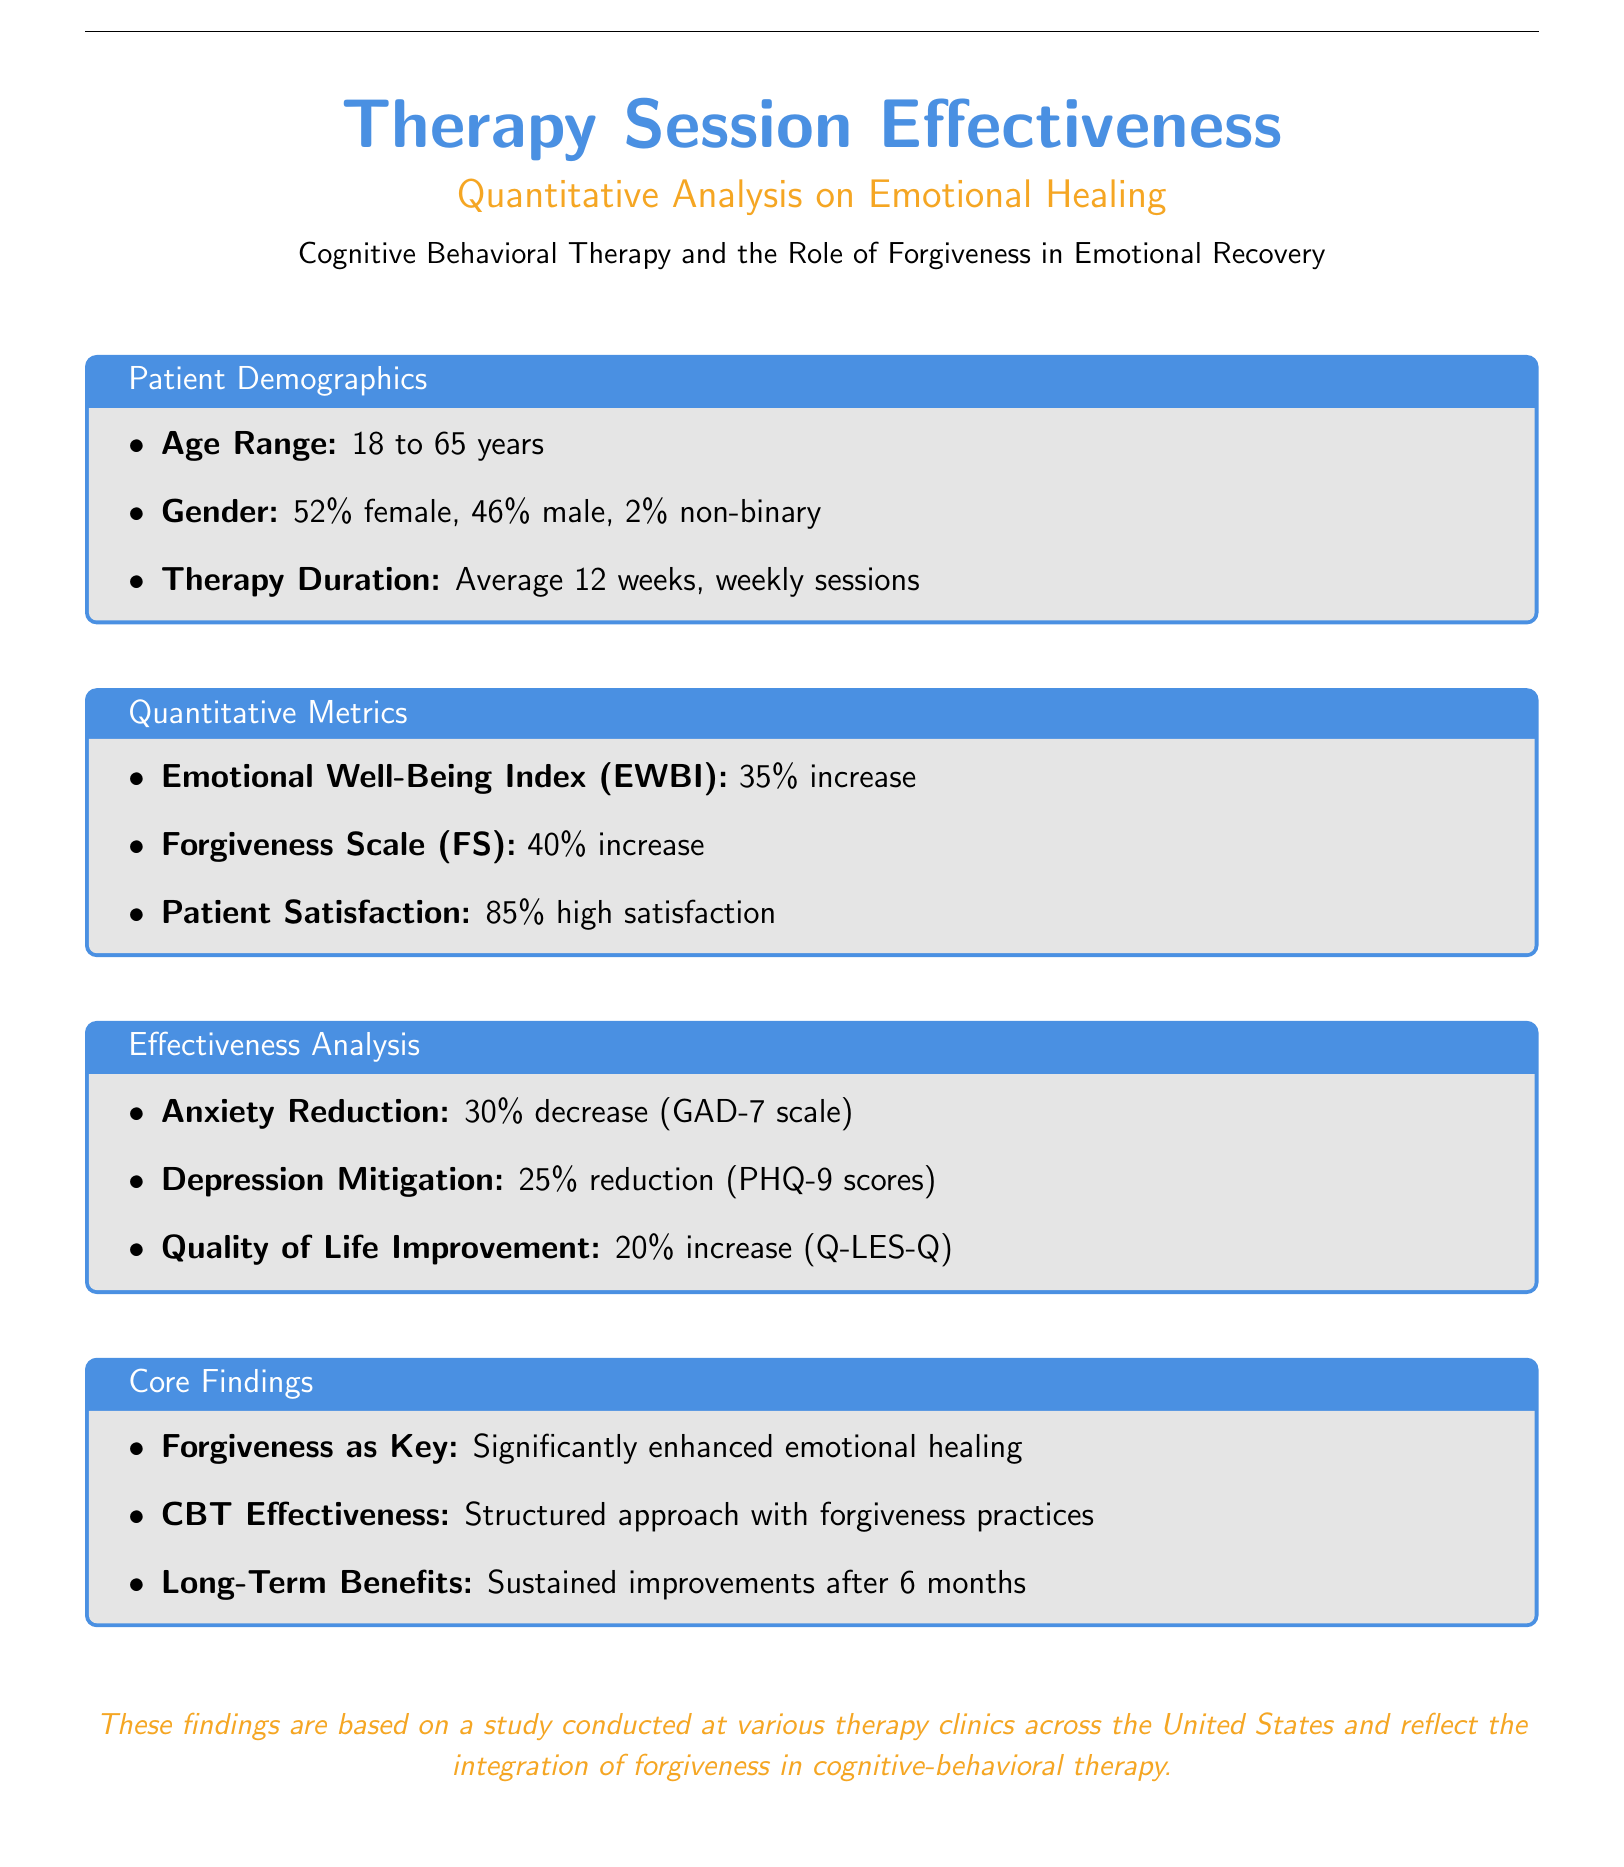What is the average therapy duration? The average therapy duration is mentioned specifically in the Patient Demographics section of the document.
Answer: 12 weeks What percentage of patients reported high satisfaction? Patient satisfaction is quantified in the Quantitative Metrics section of the document.
Answer: 85% What is the increase in the Emotional Well-Being Index? The increase in the Emotional Well-Being Index is provided in the Quantitative Metrics section.
Answer: 35% increase What core finding highlights the role of forgiveness? The core findings indicate the significance of forgiveness in emotional healing, specifically noted in the Core Findings section.
Answer: Forgiveness as Key What is the percentage decrease in anxiety according to the GAD-7 scale? The decrease in anxiety is quantified in the Effectiveness Analysis section and is based on standardized measures.
Answer: 30% decrease What area saw a 25% reduction in scores? The area that saw a 25% reduction is given in the Effectiveness Analysis, specifically referring to measurements related to patient states.
Answer: Depression Mitigation What is the percentage increase in Quality of Life Improvement? The percentage increase is discussed in the Effectiveness Analysis, detailing various outcomes.
Answer: 20% increase What long-term benefits are mentioned in the findings? The long-term benefits refer to the sustained improvements noted in the Core Findings section.
Answer: Sustained improvements after 6 months 